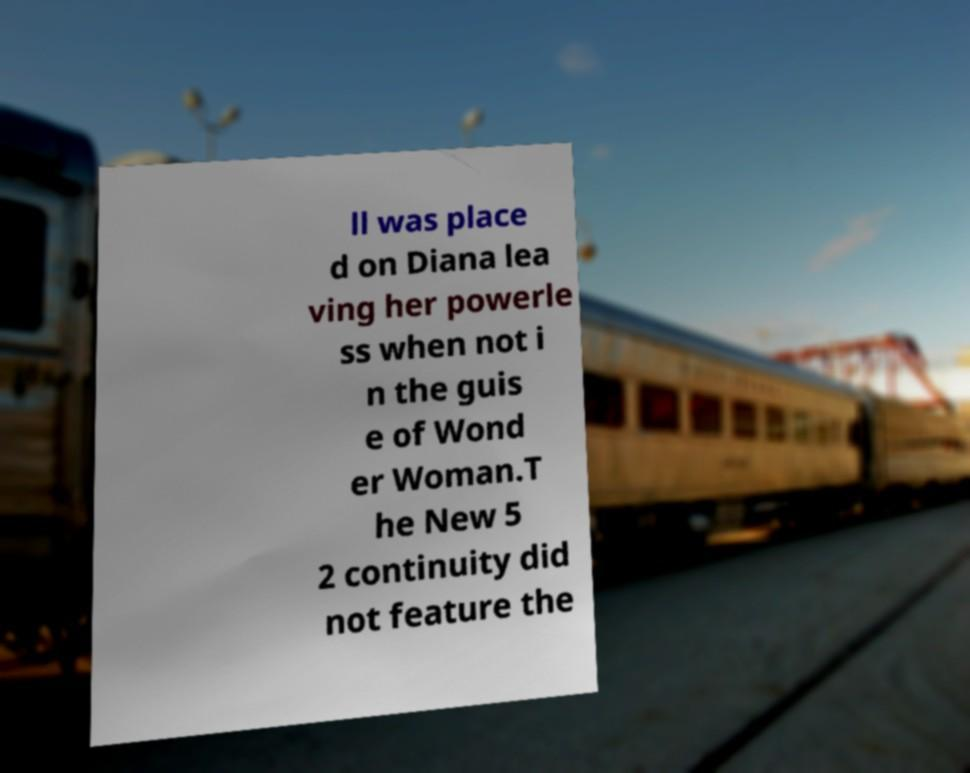I need the written content from this picture converted into text. Can you do that? ll was place d on Diana lea ving her powerle ss when not i n the guis e of Wond er Woman.T he New 5 2 continuity did not feature the 